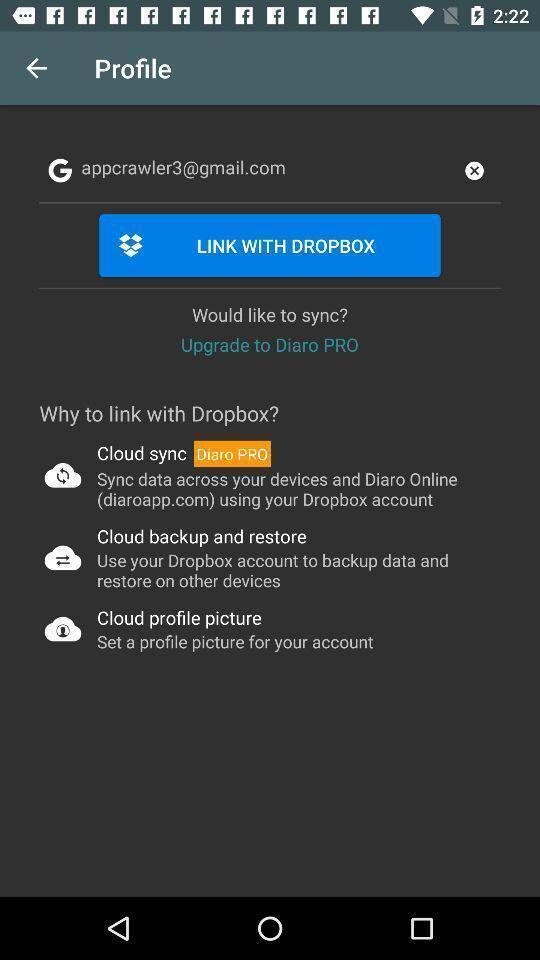Explain what's happening in this screen capture. Profile page. 